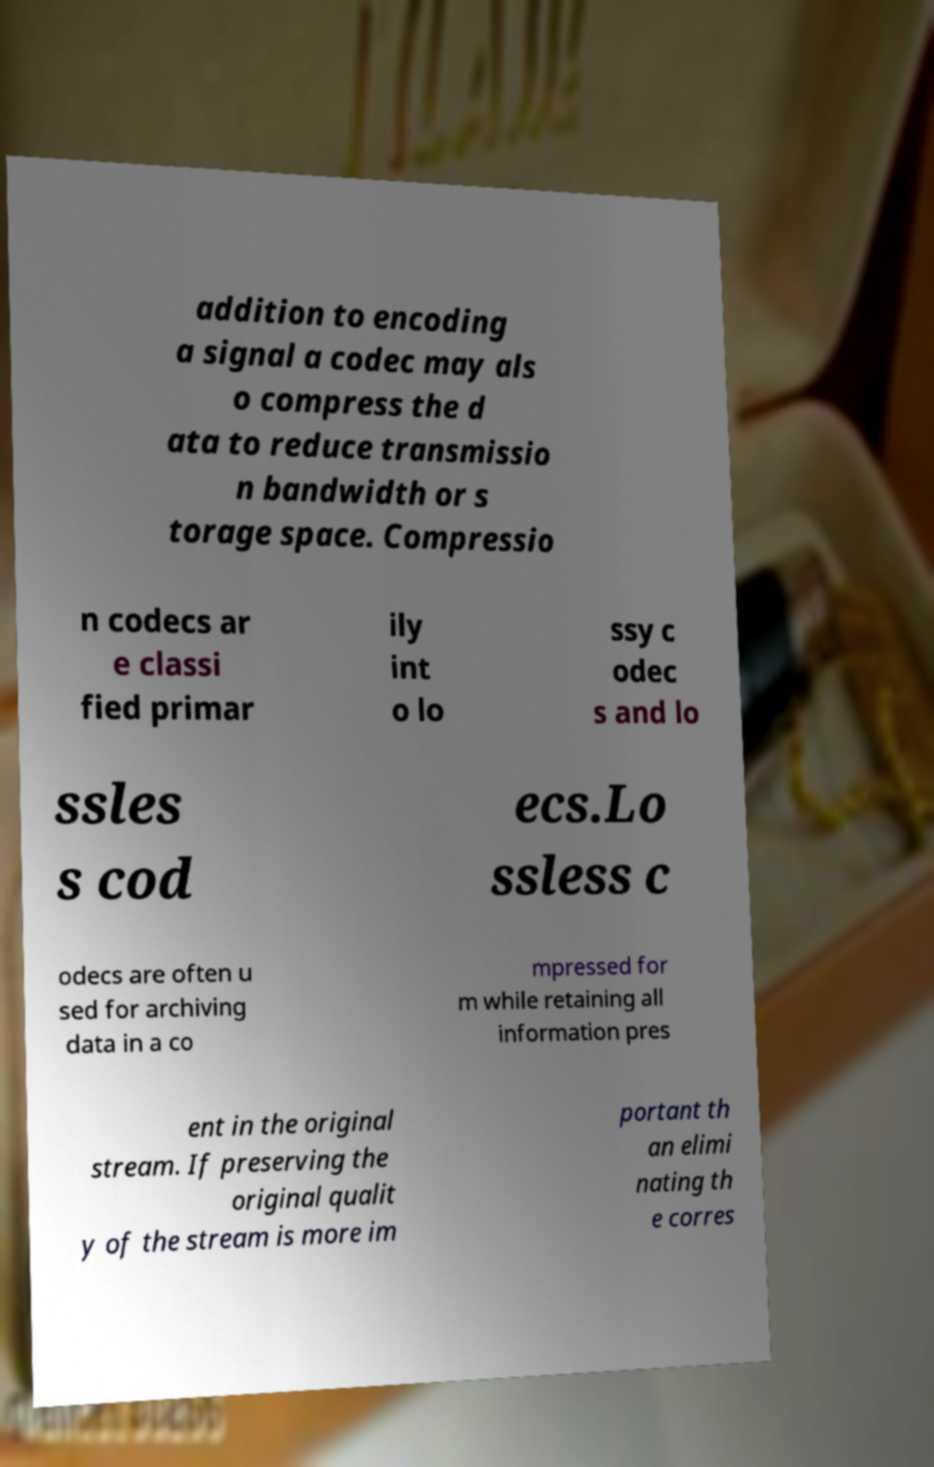Please read and relay the text visible in this image. What does it say? addition to encoding a signal a codec may als o compress the d ata to reduce transmissio n bandwidth or s torage space. Compressio n codecs ar e classi fied primar ily int o lo ssy c odec s and lo ssles s cod ecs.Lo ssless c odecs are often u sed for archiving data in a co mpressed for m while retaining all information pres ent in the original stream. If preserving the original qualit y of the stream is more im portant th an elimi nating th e corres 